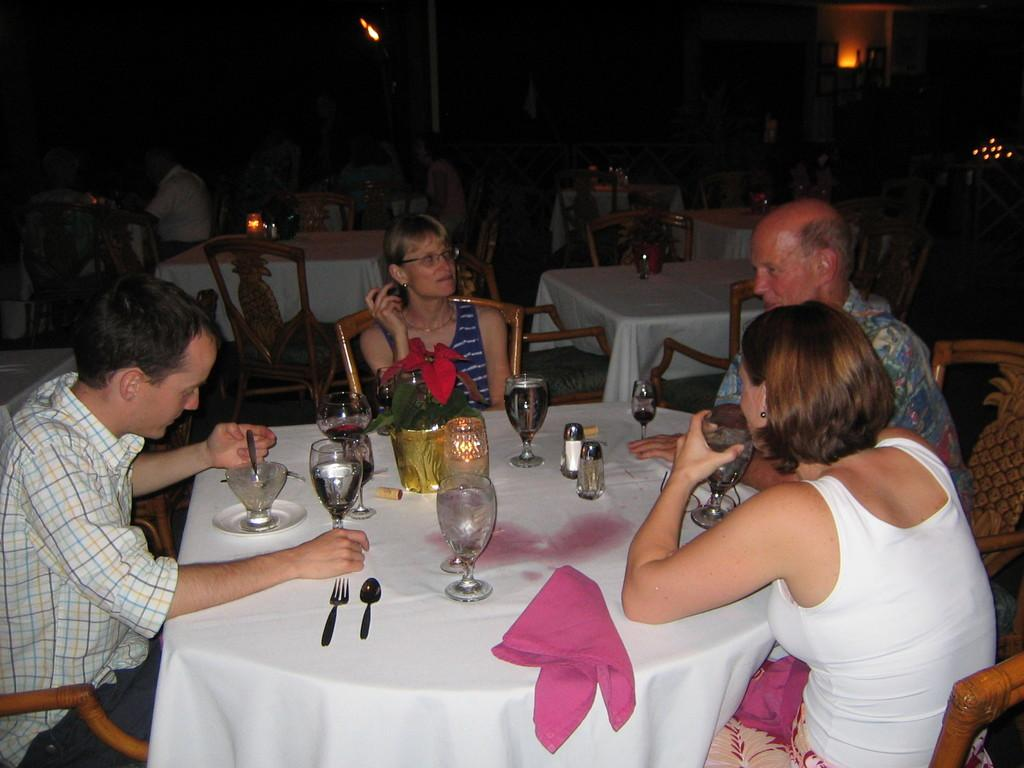How many people are in the image? There is a group of persons in the image, but the exact number cannot be determined from the facts provided. What are the persons in the image doing? The persons are sitting around a table and having their drinks. What utensils are present on the table? There are spoons and forks on the table. What type of tableware is present on the table? There are glasses on the table. What can be used for cleaning or wiping in the image? Napkins are present on the table for cleaning or wiping. What decorative item is on the table? There is a flower vase on the table. What type of yam is being served on the table in the image? There is no yam present in the image; the tableware consists of glasses, spoons, forks, and napkins. What noise can be heard coming from the persons in the image? The facts provided do not mention any sounds or noises in the image. 